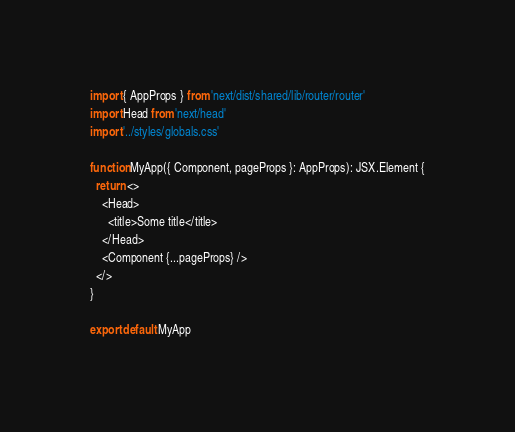Convert code to text. <code><loc_0><loc_0><loc_500><loc_500><_TypeScript_>import { AppProps } from 'next/dist/shared/lib/router/router'
import Head from 'next/head'
import '../styles/globals.css'

function MyApp({ Component, pageProps }: AppProps): JSX.Element {
  return <>
    <Head>
      <title>Some title</title>
    </Head>
    <Component {...pageProps} />
  </>
}

export default MyApp
</code> 